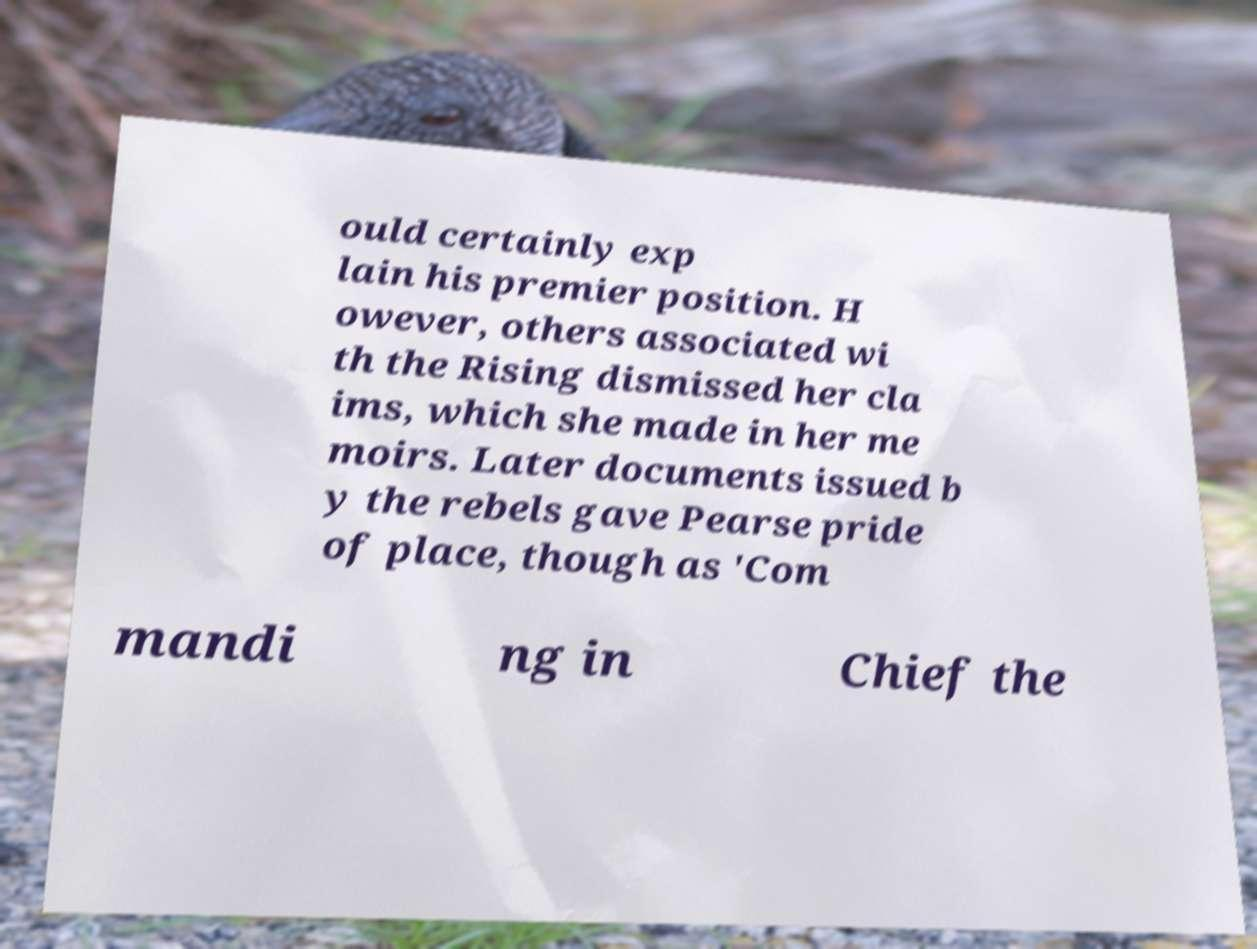Could you extract and type out the text from this image? ould certainly exp lain his premier position. H owever, others associated wi th the Rising dismissed her cla ims, which she made in her me moirs. Later documents issued b y the rebels gave Pearse pride of place, though as 'Com mandi ng in Chief the 